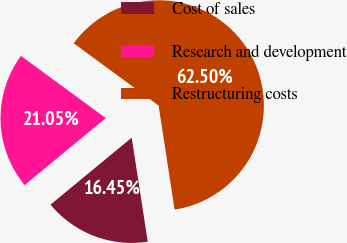Convert chart to OTSL. <chart><loc_0><loc_0><loc_500><loc_500><pie_chart><fcel>Cost of sales<fcel>Research and development<fcel>Restructuring costs<nl><fcel>16.45%<fcel>21.05%<fcel>62.5%<nl></chart> 